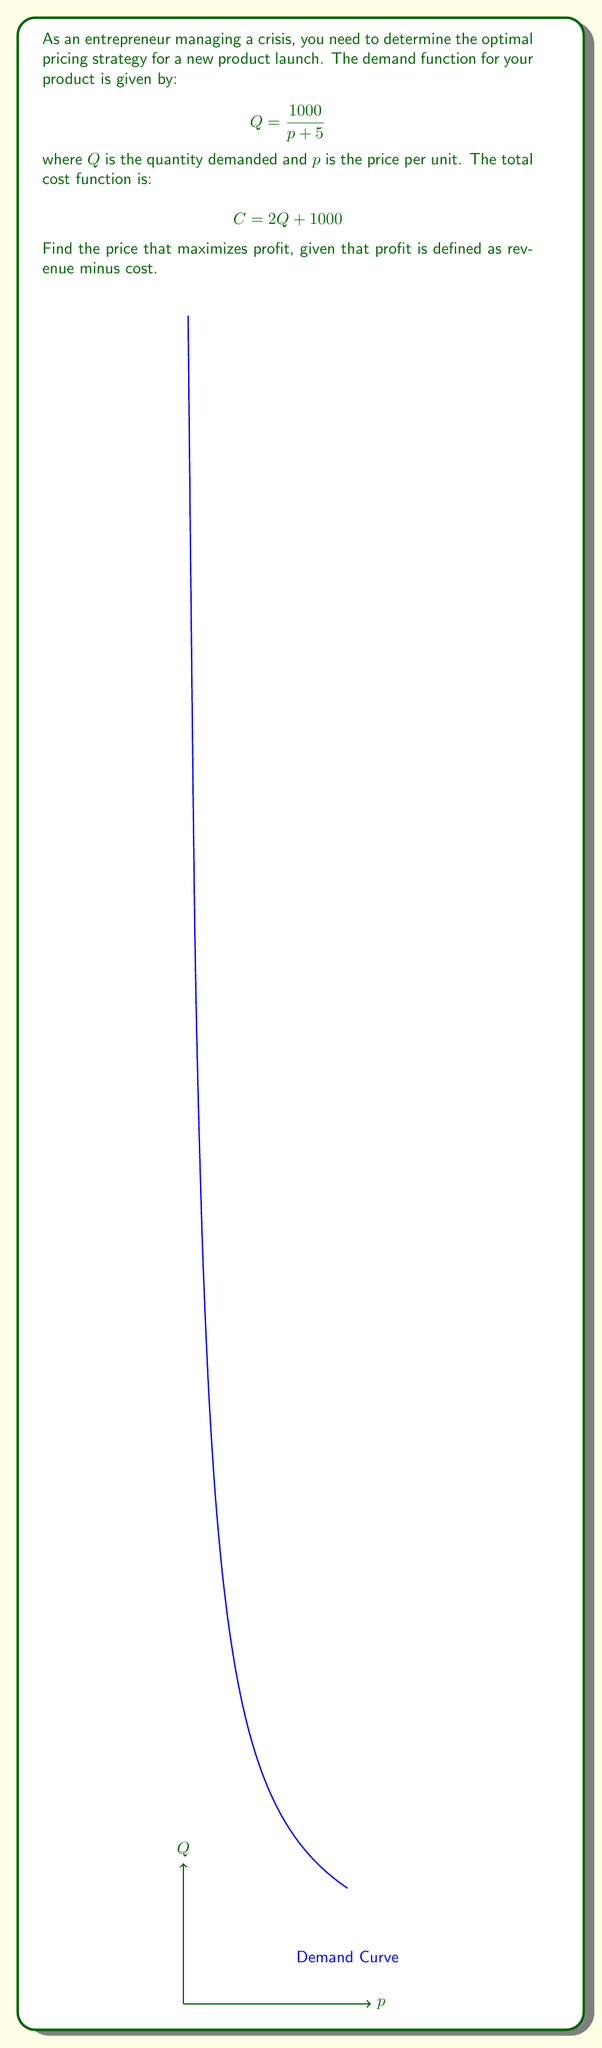Solve this math problem. 1. First, we need to express revenue (R) in terms of p:
   $$R = pQ = p \cdot \frac{1000}{p + 5}$$

2. Now, we can express cost (C) in terms of p:
   $$C = 2Q + 1000 = 2 \cdot \frac{1000}{p + 5} + 1000 = \frac{2000}{p + 5} + 1000$$

3. Profit (P) is revenue minus cost:
   $$P = R - C = p \cdot \frac{1000}{p + 5} - (\frac{2000}{p + 5} + 1000)$$

4. Simplify the profit function:
   $$P = \frac{1000p}{p + 5} - \frac{2000}{p + 5} - 1000 = \frac{1000p - 2000}{p + 5} - 1000$$

5. To find the maximum profit, we need to find where the derivative of P with respect to p equals zero:
   $$\frac{dP}{dp} = \frac{1000(p + 5) - 1000(1000p - 2000)}{(p + 5)^2} = 0$$

6. Simplify and solve for p:
   $$1000(p + 5) - 1000(1000p - 2000) = 0$$
   $$p + 5 - 1000p + 2000 = 0$$
   $$-999p + 2005 = 0$$
   $$p = \frac{2005}{999} \approx 2.01$$

7. Verify that this is a maximum by checking the second derivative is negative at this point.

Therefore, the price that maximizes profit is approximately $2.01 per unit.
Answer: $2.01 